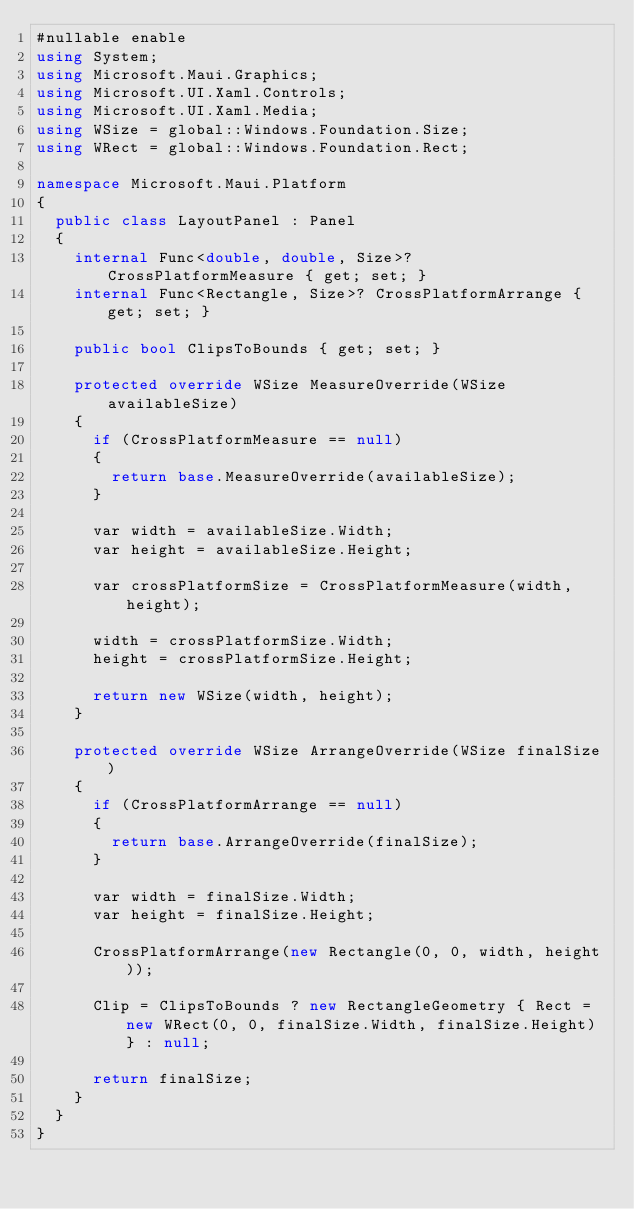<code> <loc_0><loc_0><loc_500><loc_500><_C#_>#nullable enable
using System;
using Microsoft.Maui.Graphics;
using Microsoft.UI.Xaml.Controls;
using Microsoft.UI.Xaml.Media;
using WSize = global::Windows.Foundation.Size;
using WRect = global::Windows.Foundation.Rect;

namespace Microsoft.Maui.Platform
{
	public class LayoutPanel : Panel
	{
		internal Func<double, double, Size>? CrossPlatformMeasure { get; set; }
		internal Func<Rectangle, Size>? CrossPlatformArrange { get; set; }

		public bool ClipsToBounds { get; set; }

		protected override WSize MeasureOverride(WSize availableSize)
		{
			if (CrossPlatformMeasure == null)
			{
				return base.MeasureOverride(availableSize);
			}

			var width = availableSize.Width;
			var height = availableSize.Height;

			var crossPlatformSize = CrossPlatformMeasure(width, height);

			width = crossPlatformSize.Width;
			height = crossPlatformSize.Height;

			return new WSize(width, height);
		}

		protected override WSize ArrangeOverride(WSize finalSize)
		{
			if (CrossPlatformArrange == null)
			{
				return base.ArrangeOverride(finalSize);
			}

			var width = finalSize.Width;
			var height = finalSize.Height;

			CrossPlatformArrange(new Rectangle(0, 0, width, height));

			Clip = ClipsToBounds ? new RectangleGeometry { Rect = new WRect(0, 0, finalSize.Width, finalSize.Height) } : null;

			return finalSize;
		}
	}
}
</code> 